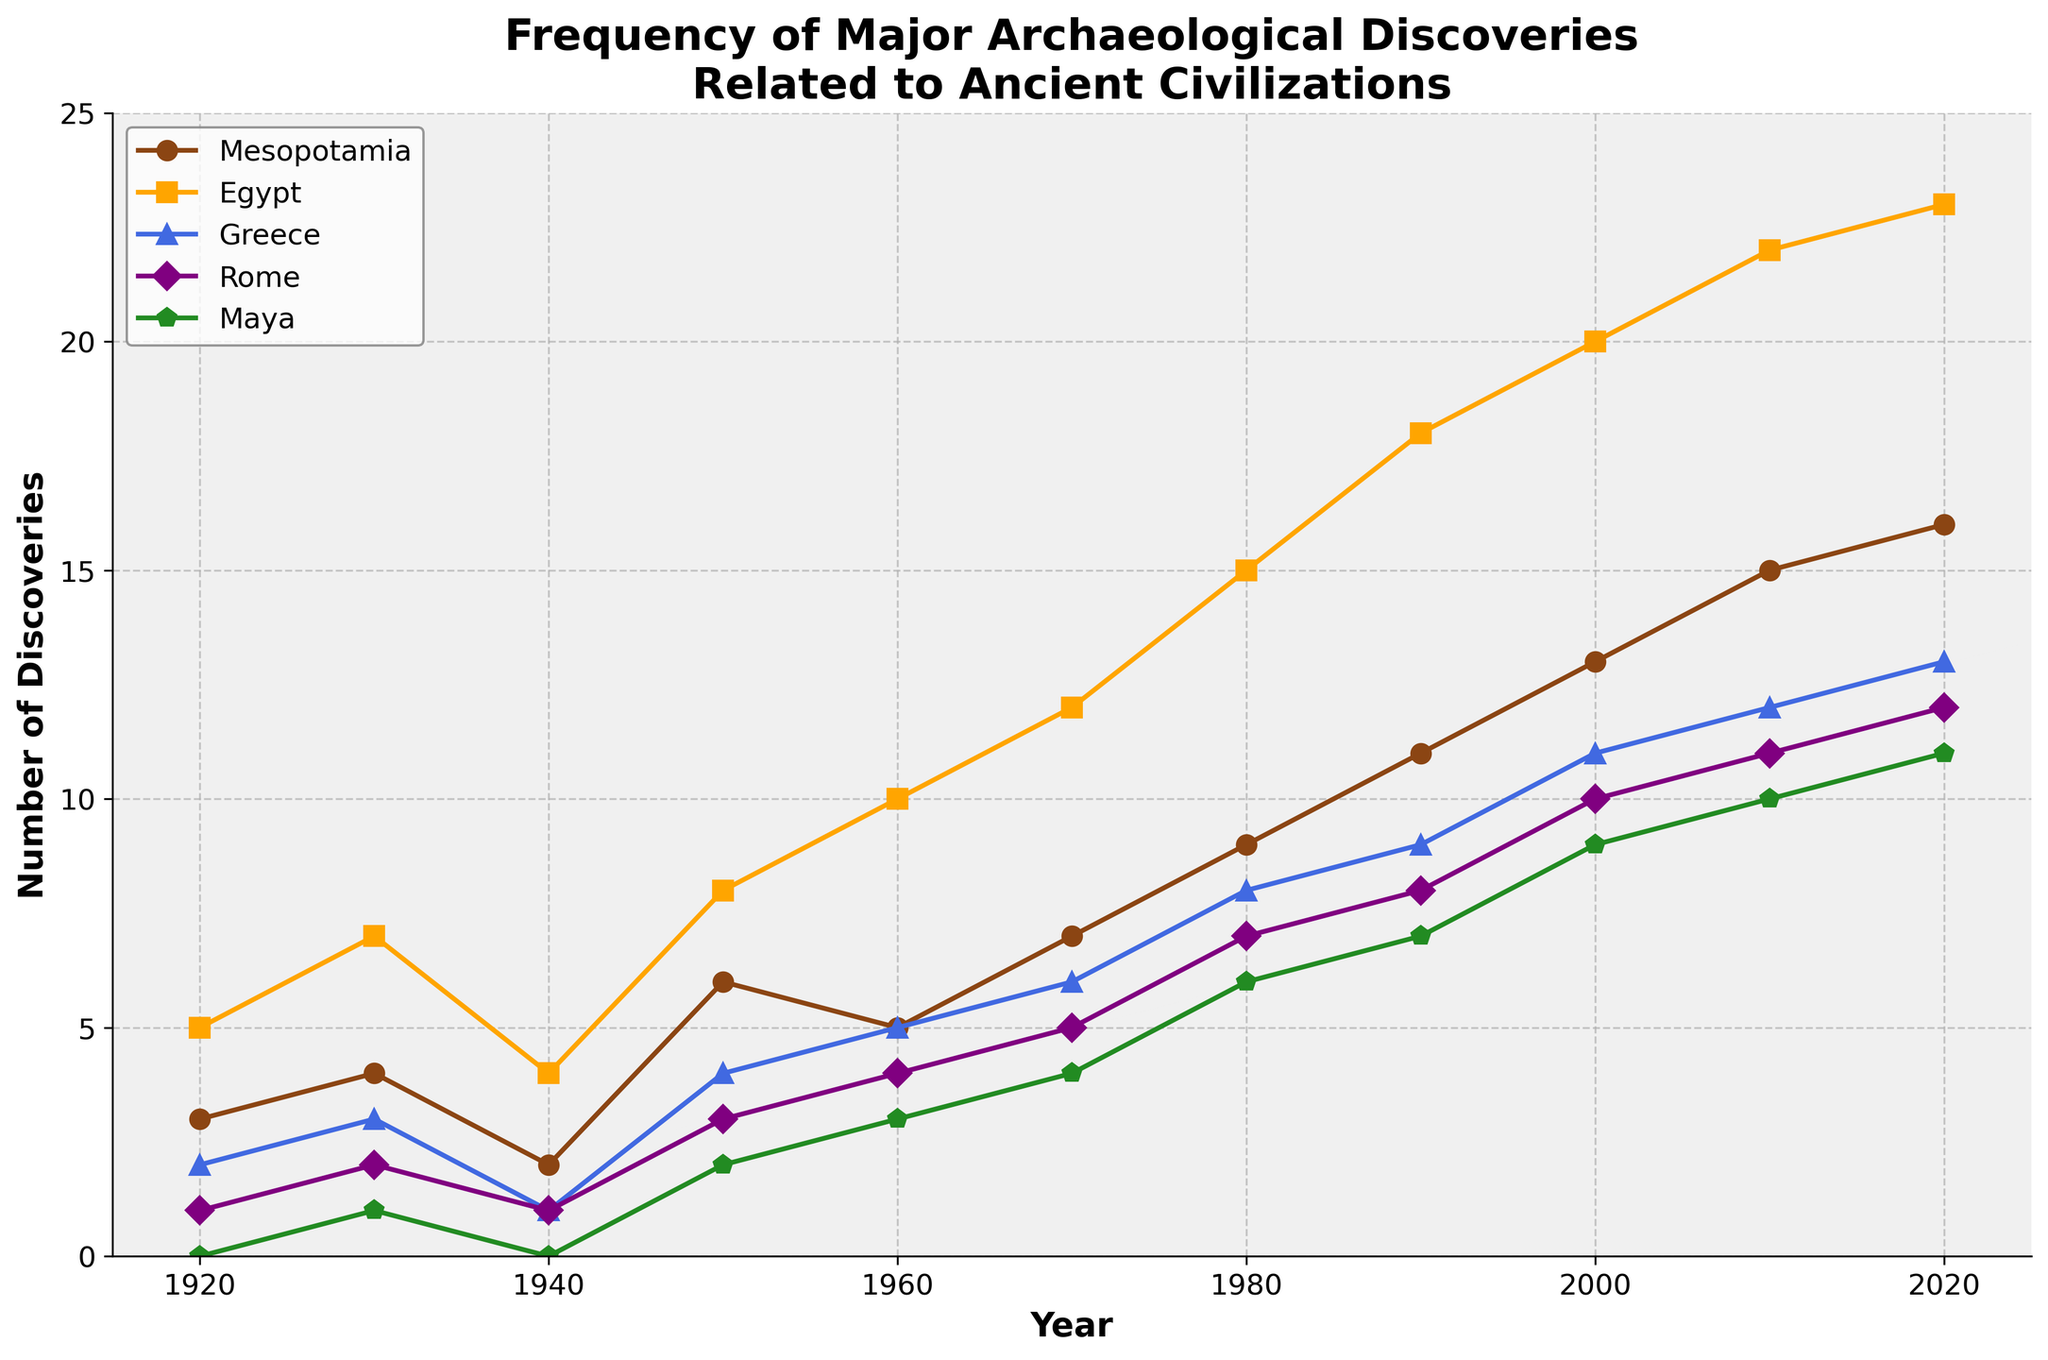How many more discoveries were made in Egypt than in Mesopotamia in 2010? In 2010, the number of discoveries made in Egypt was 22, and in Mesopotamia was 15. The difference is 22 - 15.
Answer: 7 Which civilization had the highest number of discoveries in 1980? In 1980, the plots for each civilization show: Mesopotamia with 9, Egypt with 15, Greece with 8, Rome with 7, and Maya with 6. Egypt is the highest.
Answer: Egypt Between 1960 and 2000, which civilization experienced the greatest increase in the number of discoveries? The increase for each civilization is calculated by subtracting the value in 1960 from the value in 2000. For Mesopotamia, it's 13 - 5 = 8; for Egypt, 20 - 10 = 10; for Greece, 11 - 5 = 6; for Rome, 10 - 4 = 6; for Maya, 9 - 3 = 6. Egypt has the greatest increase.
Answer: Egypt How many total discoveries were made in Rome and Greece combined in 1970? In 1970, Rome had 5 discoveries, and Greece had 6. The combined total is 5 + 6.
Answer: 11 What is the average number of discoveries in Mesopotamia across the entire century shown in the chart? Sum all the discoveries from Mesopotamia across the years (3, 4, 2, 6, 5, 7, 9, 11, 13, 15, 16) which totals 91, and divide by the number of years (11). The average is 91 / 11.
Answer: 8.27 In which year did Maya surpass 5 discoveries for the first time? The value for Maya is first greater than 5 in 1960, where it is 6.
Answer: 1960 Between 1930 and 1940, did the number of discoveries in Egypt increase or decrease, and by how much? In 1930, Egypt had 7 discoveries, and in 1940, it had 4. The number of discoveries decreased by 7 - 4.
Answer: Decrease, by 3 How many discoveries were made in Mesopotamia and Egypt combined in 2020? In 2020, Mesopotamia had 16 discoveries, and Egypt had 23. The combined total is 16 + 23.
Answer: 39 